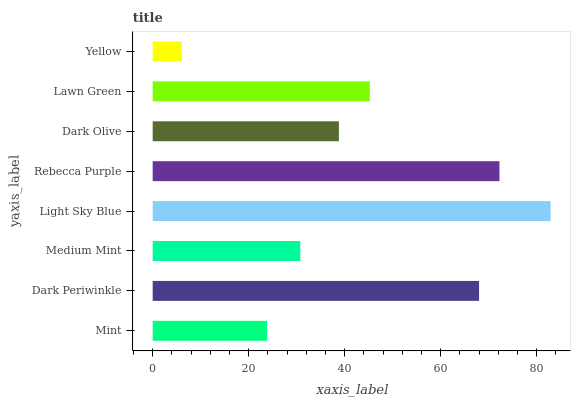Is Yellow the minimum?
Answer yes or no. Yes. Is Light Sky Blue the maximum?
Answer yes or no. Yes. Is Dark Periwinkle the minimum?
Answer yes or no. No. Is Dark Periwinkle the maximum?
Answer yes or no. No. Is Dark Periwinkle greater than Mint?
Answer yes or no. Yes. Is Mint less than Dark Periwinkle?
Answer yes or no. Yes. Is Mint greater than Dark Periwinkle?
Answer yes or no. No. Is Dark Periwinkle less than Mint?
Answer yes or no. No. Is Lawn Green the high median?
Answer yes or no. Yes. Is Dark Olive the low median?
Answer yes or no. Yes. Is Mint the high median?
Answer yes or no. No. Is Yellow the low median?
Answer yes or no. No. 